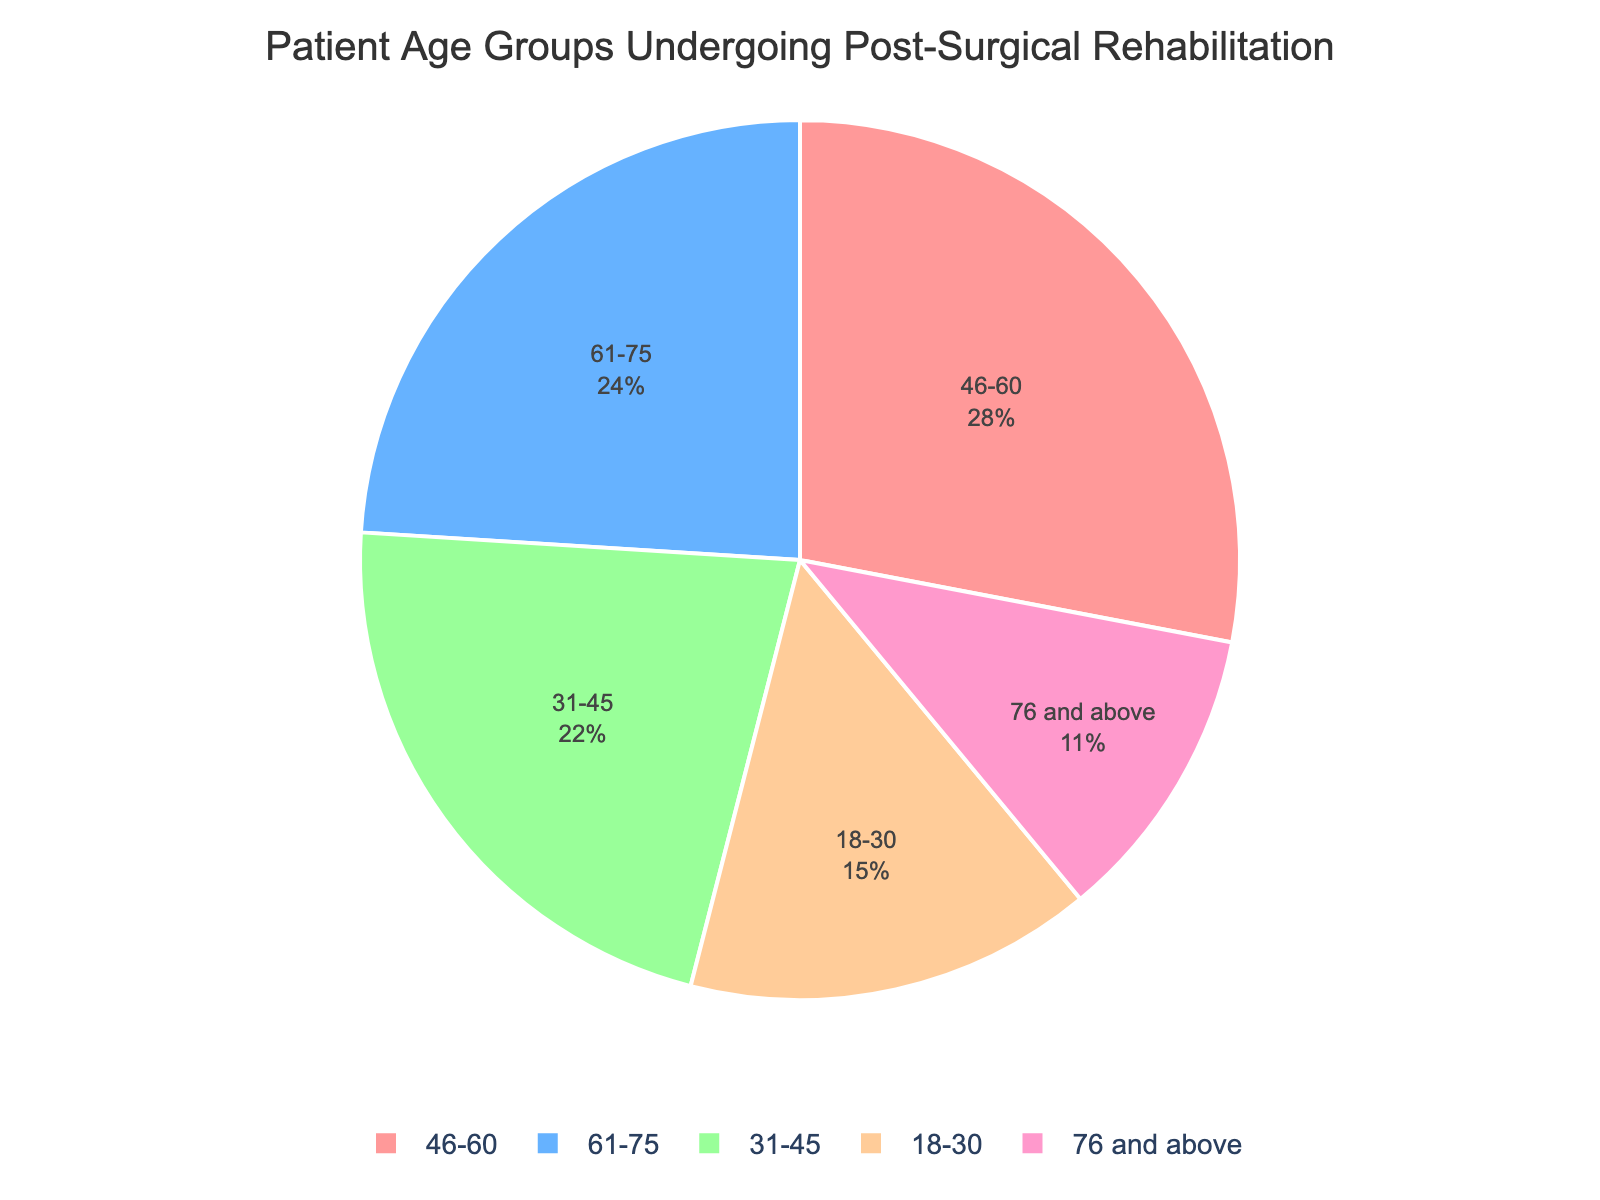What age group has the highest percentage of patients undergoing post-surgical rehabilitation? The pie chart shows each age group's percentage. The age group 46-60 has the highest percentage at 28%.
Answer: 46-60 Which age group has the lowest percentage of patients? By looking at the pie chart, the group 76 and above has the lowest percentage, which is 11%.
Answer: 76 and above How does the percentage of the 31-45 age group compare to the 76 and above age group? The pie chart shows that the 31-45 age group is 22% and the 76 and above age group is 11%. So, the 31-45 age group is greater by 11%.
Answer: 31-45 is greater by 11% What is the combined percentage of the youngest and oldest age groups? The pie chart indicates the percentages for the youngest (18-30) and oldest (76 and above) age groups as 15% and 11%, respectively. Adding these gives 15% + 11% = 26%.
Answer: 26% What's the difference in percentage between the 61-75 and 31-45 age groups? The pie chart shows that the 61-75 age group is 24% and the 31-45 age group is 22%. The difference between these two is 24% - 22% = 2%.
Answer: 2% Are there more patients in the 61-75 age group or in the 46-60 age group? The pie chart indicates that the 46-60 age group has a percentage of 28%, while the 61-75 age group has 24%. Therefore, there are more patients in the 46-60 age group.
Answer: 46-60 What is the total percentage for age groups 31-45 and 46-60 combined? Summing up the percentages provided in the pie chart for age groups 31-45 (22%) and 46-60 (28%) gives 22% + 28% = 50%.
Answer: 50% Which age group is represented by the color blue? By referring to the customized color sequence provided, the blue color corresponds to the second segment, which is the 31-45 age group.
Answer: 31-45 How many age groups have a percentage above 20%? The pie chart clearly shows that the age groups 31-45 (22%), 46-60 (28%), and 61-75 (24%) all have percentages above 20%, making a total of three groups.
Answer: Three Which two age groups have a combined percentage that is less than the 46-60 age group? Adding the percentages of the two smallest groups, 18-30 (15%) and 76 and above (11%), gives 15% + 11% = 26%, which is less than the 28% of the 46-60 age group.
Answer: 18-30 and 76 and above 